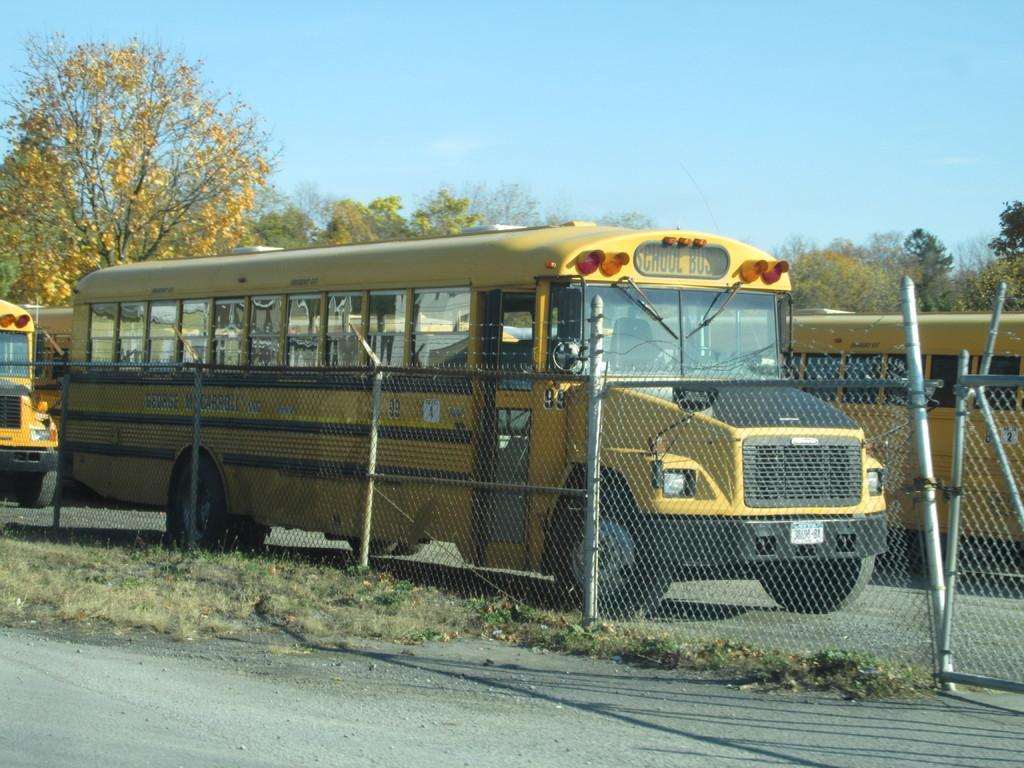What type of vehicles can be seen on the road in the image? There are buses on the road in the image. What can be seen in the background of the image? There are trees in the background of the image. What type of material is visible in the image? There is a mesh visible in the image. What is visible at the top of the image? The sky is visible at the top of the image. Can you see a plough working in the fields in the image? There is no plough or fields present in the image; it features buses on the road, trees in the background, a mesh, and the sky. 